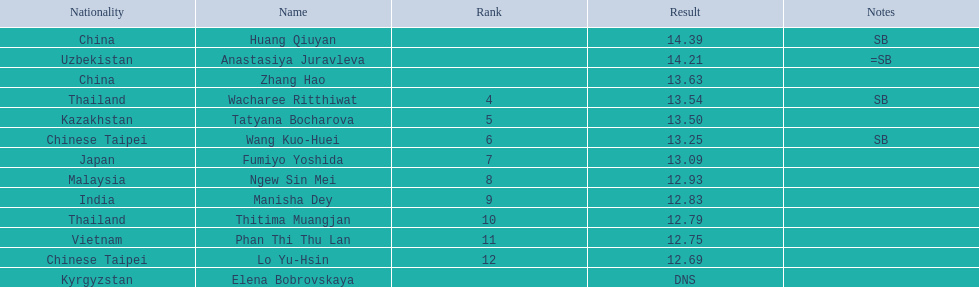Which country came in first? China. 